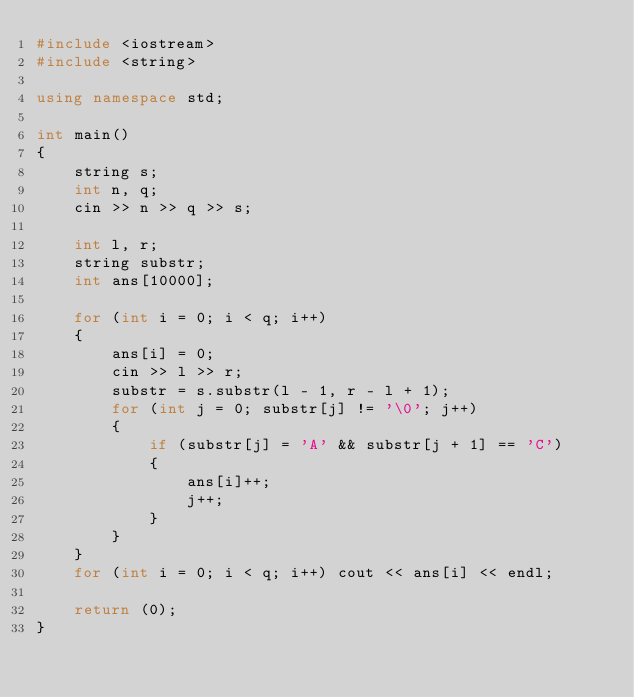Convert code to text. <code><loc_0><loc_0><loc_500><loc_500><_C++_>#include <iostream>
#include <string>

using namespace std;

int main()
{
    string s;
    int n, q;
    cin >> n >> q >> s;

    int l, r;
    string substr;
    int ans[10000];

    for (int i = 0; i < q; i++)
    {
        ans[i] = 0;
        cin >> l >> r;
        substr = s.substr(l - 1, r - l + 1);
        for (int j = 0; substr[j] != '\0'; j++)
        {
            if (substr[j] = 'A' && substr[j + 1] == 'C')
            {
                ans[i]++;
                j++;
            }
        }
    }
    for (int i = 0; i < q; i++) cout << ans[i] << endl;

    return (0);
}</code> 